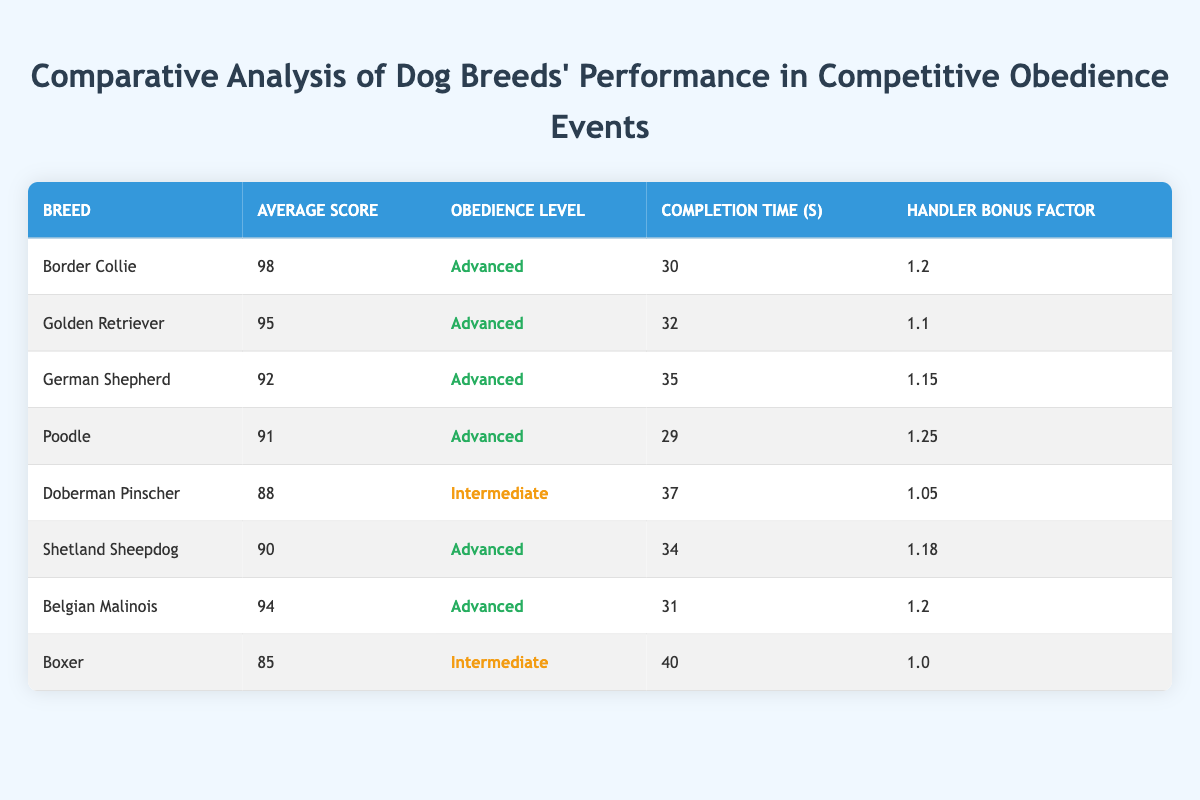What is the average score of the Poodle? According to the table, the average score of the Poodle is listed as 91.
Answer: 91 Which breed has the longest completion time? The breed with the longest completion time is the Boxer, with a time of 40 seconds.
Answer: Boxer Is the Golden Retriever's obedience level classified as Advanced? Yes, the Golden Retriever is classified as having an Advanced obedience level according to the table.
Answer: Yes What is the difference in average scores between the Border Collie and the Doberman Pinscher? The average score of the Border Collie is 98 and the Doberman Pinscher is 88. The difference is 98 - 88 = 10.
Answer: 10 Which breeds have an average score of 90 or above? The breeds with an average score of 90 or above are: Border Collie (98), Golden Retriever (95), German Shepherd (92), Poodle (91), Belgian Malinois (94), and Shetland Sheepdog (90).
Answer: Border Collie, Golden Retriever, German Shepherd, Poodle, Belgian Malinois, Shetland Sheepdog What is the average completion time for dogs with an Advanced obedience level? The breeds with Advanced obedience level and their completion times are: Border Collie (30), Golden Retriever (32), German Shepherd (35), Poodle (29), Shetland Sheepdog (34), and Belgian Malinois (31). To find the average, we sum these times (30 + 32 + 35 + 29 + 34 + 31 = 191) and divide by the number of breeds (6): 191/6 = approximately 31.83 seconds.
Answer: 31.83 seconds 